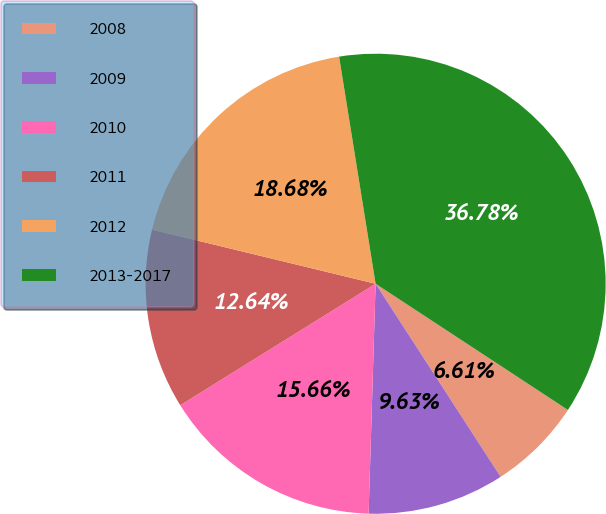Convert chart to OTSL. <chart><loc_0><loc_0><loc_500><loc_500><pie_chart><fcel>2008<fcel>2009<fcel>2010<fcel>2011<fcel>2012<fcel>2013-2017<nl><fcel>6.61%<fcel>9.63%<fcel>15.66%<fcel>12.64%<fcel>18.68%<fcel>36.78%<nl></chart> 